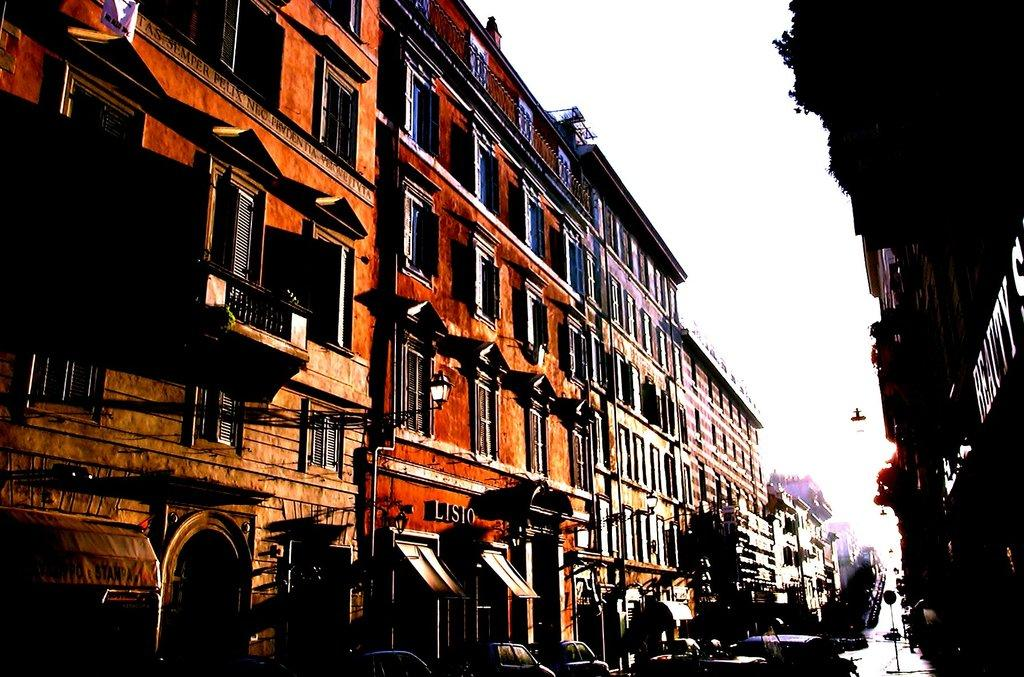What type of structures can be seen in the image? There are buildings in the image. What type of vehicles are visible at the bottom of the image? Cars are visible at the bottom of the image. What part of the natural environment is visible in the image? The sky is visible in the background of the image. How many rings can be seen on the fish's leg in the image? There are no fish or legs with rings present in the image. 